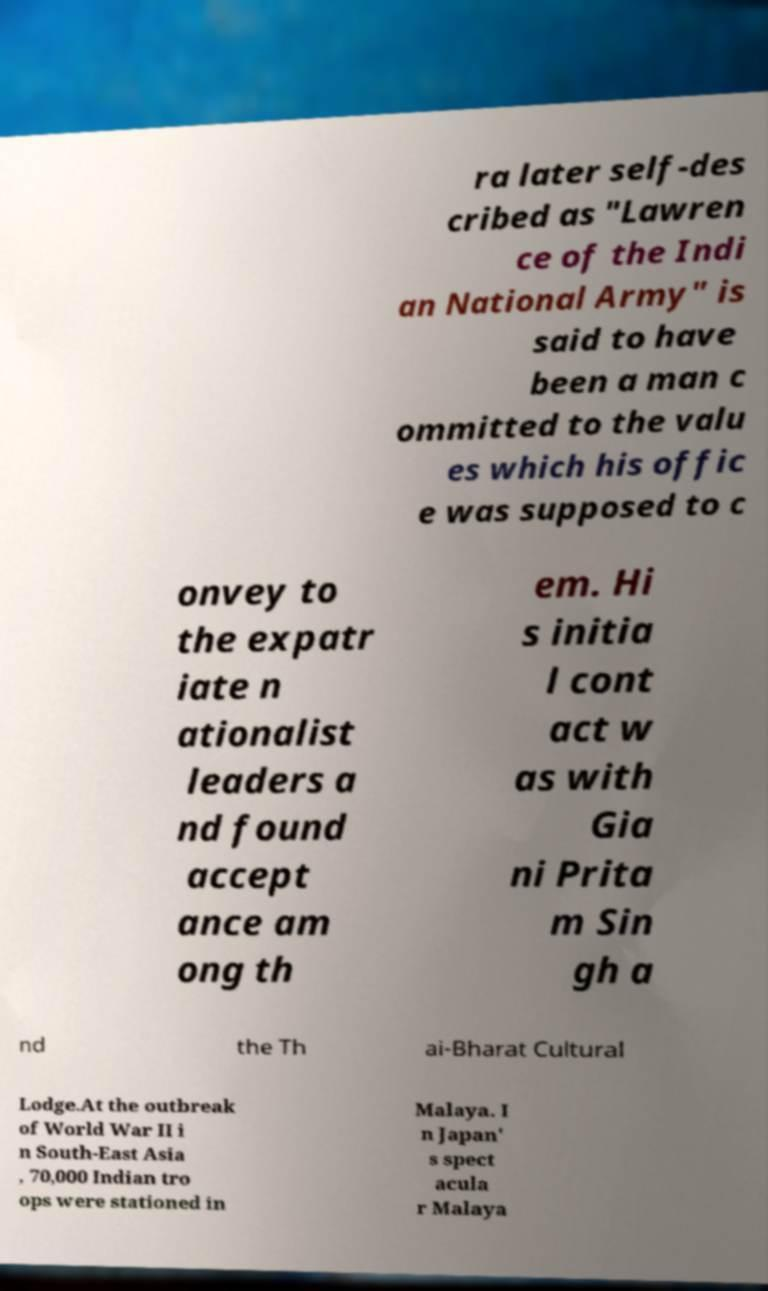Please identify and transcribe the text found in this image. ra later self-des cribed as "Lawren ce of the Indi an National Army" is said to have been a man c ommitted to the valu es which his offic e was supposed to c onvey to the expatr iate n ationalist leaders a nd found accept ance am ong th em. Hi s initia l cont act w as with Gia ni Prita m Sin gh a nd the Th ai-Bharat Cultural Lodge.At the outbreak of World War II i n South-East Asia , 70,000 Indian tro ops were stationed in Malaya. I n Japan' s spect acula r Malaya 